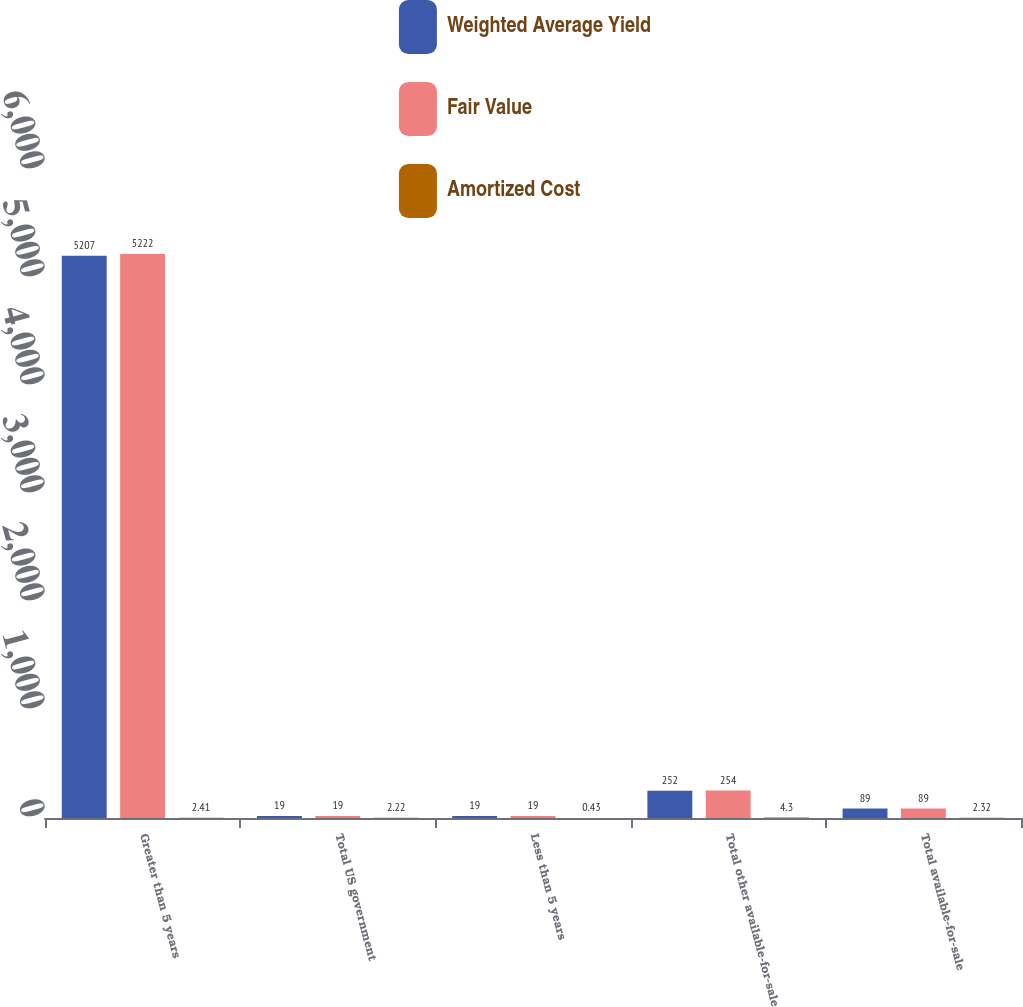<chart> <loc_0><loc_0><loc_500><loc_500><stacked_bar_chart><ecel><fcel>Greater than 5 years<fcel>Total US government<fcel>Less than 5 years<fcel>Total other available-for-sale<fcel>Total available-for-sale<nl><fcel>Weighted Average Yield<fcel>5207<fcel>19<fcel>19<fcel>252<fcel>89<nl><fcel>Fair Value<fcel>5222<fcel>19<fcel>19<fcel>254<fcel>89<nl><fcel>Amortized Cost<fcel>2.41<fcel>2.22<fcel>0.43<fcel>4.3<fcel>2.32<nl></chart> 